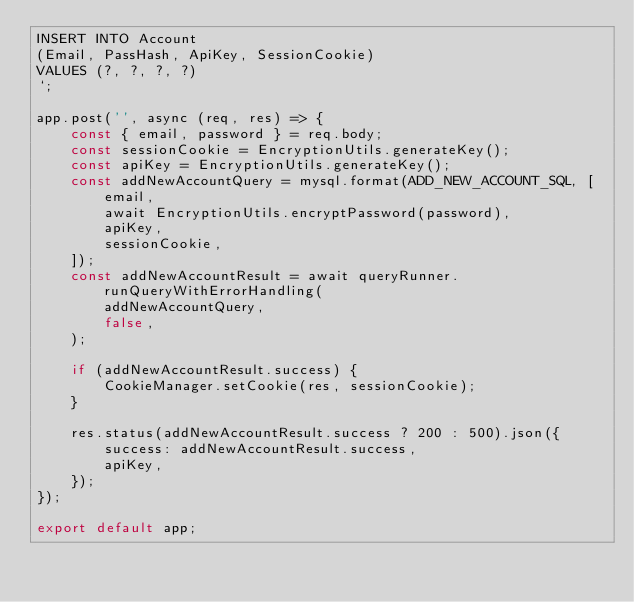Convert code to text. <code><loc_0><loc_0><loc_500><loc_500><_TypeScript_>INSERT INTO Account
(Email, PassHash, ApiKey, SessionCookie)
VALUES (?, ?, ?, ?)
`;

app.post('', async (req, res) => {
    const { email, password } = req.body;
    const sessionCookie = EncryptionUtils.generateKey();
    const apiKey = EncryptionUtils.generateKey();
    const addNewAccountQuery = mysql.format(ADD_NEW_ACCOUNT_SQL, [
        email,
        await EncryptionUtils.encryptPassword(password),
        apiKey,
        sessionCookie,
    ]);
    const addNewAccountResult = await queryRunner.runQueryWithErrorHandling(
        addNewAccountQuery,
        false,
    );

    if (addNewAccountResult.success) {
        CookieManager.setCookie(res, sessionCookie);
    }

    res.status(addNewAccountResult.success ? 200 : 500).json({
        success: addNewAccountResult.success,
        apiKey,
    });
});

export default app;
</code> 